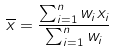Convert formula to latex. <formula><loc_0><loc_0><loc_500><loc_500>\overline { x } = \frac { \sum _ { i = 1 } ^ { n } w _ { i } x _ { i } } { \sum _ { i = 1 } ^ { n } w _ { i } } \,</formula> 